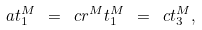<formula> <loc_0><loc_0><loc_500><loc_500>a t _ { 1 } ^ { M } \ = \ c r ^ { M } t _ { 1 } ^ { M } \ = \ c t _ { 3 } ^ { M } ,</formula> 